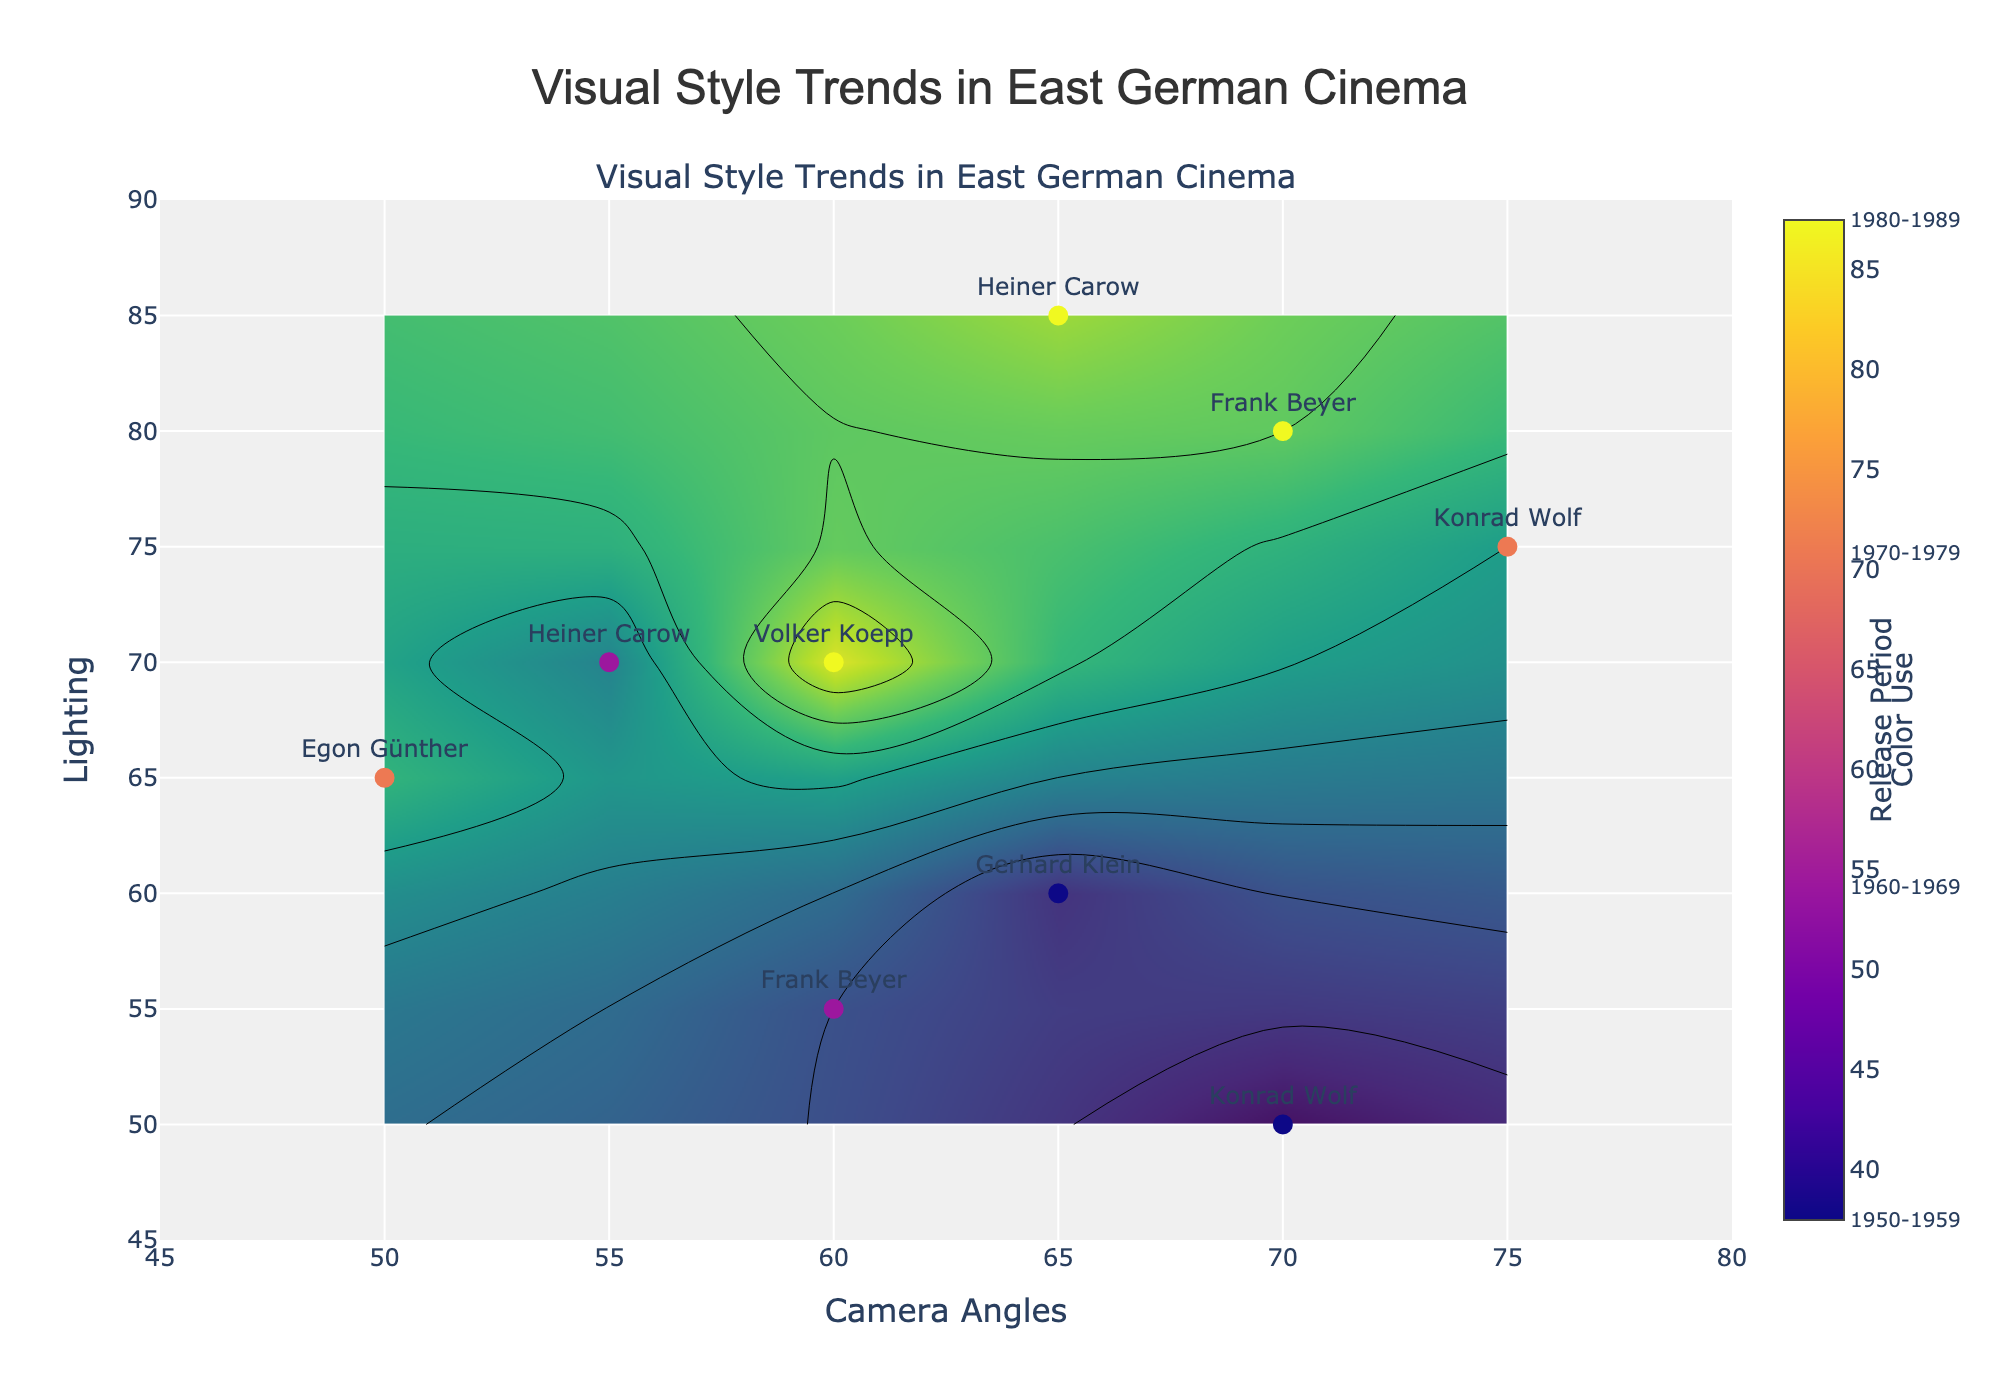What is the title of the plot? The title is prominently displayed on top of the plot. It reads "Visual Style Trends in East German Cinema".
Answer: Visual Style Trends in East German Cinema What does the color bar on the right represent? The color bar on the right indicates the "Color Use" values, and it is colored with a gradient. It helps to interpret the intensity of color use based on different visual styles.
Answer: Color Use How many data points are represented in the scatter plot? The scatter plot points are marked with director names. By counting each unique director label, you can see a total of nine points
Answer: 9 Which director has the highest lighting value in the 1980-1989 release period? To find this, look at the points labeled with director names and colored according to the release period. In the 1980-1989 period, Heiner Carow has the highest lighting value, which is 85.
Answer: Heiner Carow Do Kameral angles generally increase or decrease over the decades? By observing the scatter points and their corresponding camera angles, we can see that camera angles generally increase over the decades, peaking in the 1970-1979 period.
Answer: Increase Which period shows the most variation in lighting? Look at the spread of lighting values within each release period. The 1980-1989 period has the most significant range of lighting values from 70 to 85, showing the most variation.
Answer: 1980-1989 Who has a combination of the highest camera angles and color use? Observe the scatter plot for both the highest camera angle and color use. Konrad Wolf in the 1970-1979 period has the highest combination values (Camera Angles: 75, Color Use: 65).
Answer: Konrad Wolf What is the average Color Use for films released in the 1960-1969 period? There are two data points for this period, with color uses of 50 and 60. The average is calculated as (50 + 60) / 2.
Answer: 55 Which director appears more than once in different release periods? By checking the directors' names across the scatter points, Konrad Wolf is present in both the 1950-1959 and 1970-1979 periods.
Answer: Konrad Wolf How does the lighting value for Frank Beyer in the 1980-1989 period compare to Heiner Carow in the 1960-1969 period? Frank Beyer's lighting in the 1980-1989 period is 80. Heiner Carow's lighting in the 1960-1969 period is 70. Frank Beyer's value is higher.
Answer: Frank Beyer in 1980-1989 has higher lighting 